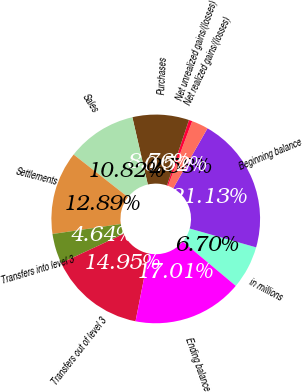Convert chart. <chart><loc_0><loc_0><loc_500><loc_500><pie_chart><fcel>in millions<fcel>Beginning balance<fcel>Net realized gains/(losses)<fcel>Net unrealized gains/(losses)<fcel>Purchases<fcel>Sales<fcel>Settlements<fcel>Transfers into level 3<fcel>Transfers out of level 3<fcel>Ending balance<nl><fcel>6.7%<fcel>21.13%<fcel>2.58%<fcel>0.52%<fcel>8.76%<fcel>10.82%<fcel>12.89%<fcel>4.64%<fcel>14.95%<fcel>17.01%<nl></chart> 